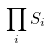<formula> <loc_0><loc_0><loc_500><loc_500>\prod _ { i } S _ { i }</formula> 